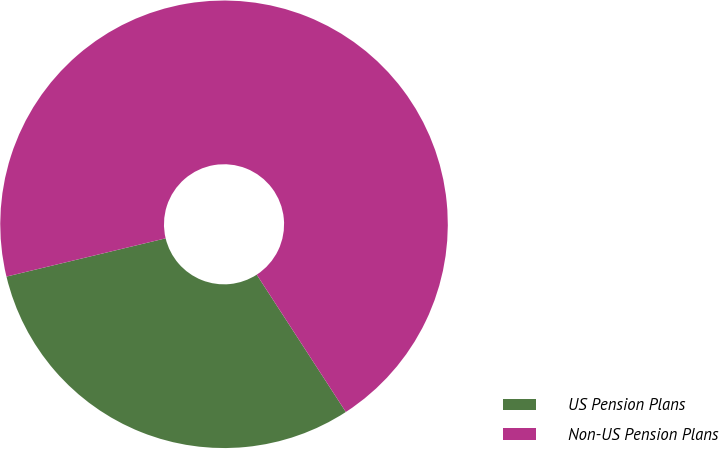Convert chart. <chart><loc_0><loc_0><loc_500><loc_500><pie_chart><fcel>US Pension Plans<fcel>Non-US Pension Plans<nl><fcel>30.41%<fcel>69.59%<nl></chart> 